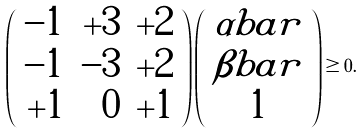Convert formula to latex. <formula><loc_0><loc_0><loc_500><loc_500>\left ( \begin{array} { r r r } - 1 & + 3 & + 2 \\ - 1 & - 3 & + 2 \\ + 1 & 0 & + 1 \end{array} \right ) \left ( \begin{array} { c } \alpha b a r \\ \beta b a r \\ 1 \end{array} \right ) \geq 0 .</formula> 